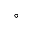Convert formula to latex. <formula><loc_0><loc_0><loc_500><loc_500>\circ</formula> 